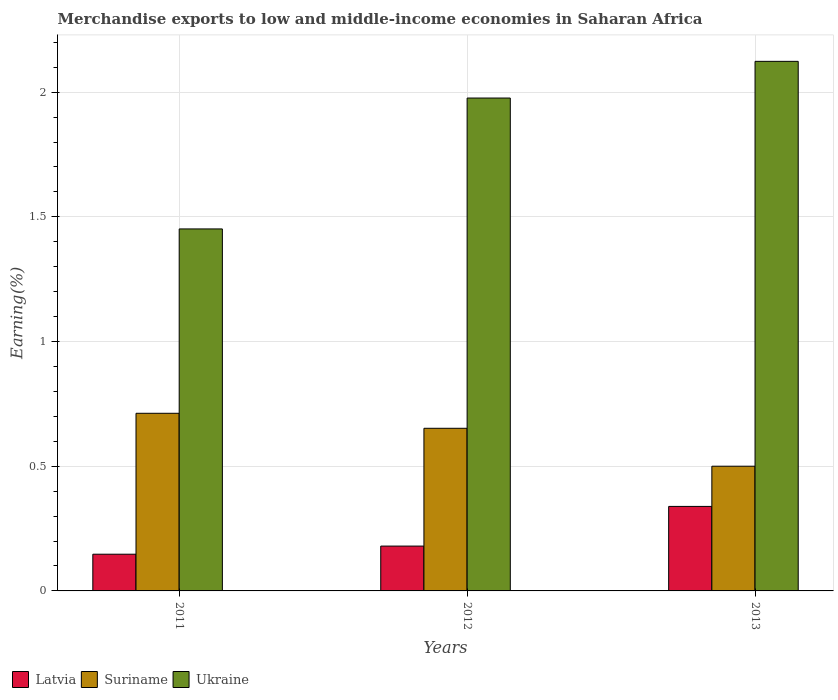What is the percentage of amount earned from merchandise exports in Suriname in 2013?
Give a very brief answer. 0.5. Across all years, what is the maximum percentage of amount earned from merchandise exports in Latvia?
Provide a succinct answer. 0.34. Across all years, what is the minimum percentage of amount earned from merchandise exports in Ukraine?
Give a very brief answer. 1.45. In which year was the percentage of amount earned from merchandise exports in Ukraine maximum?
Provide a succinct answer. 2013. In which year was the percentage of amount earned from merchandise exports in Latvia minimum?
Give a very brief answer. 2011. What is the total percentage of amount earned from merchandise exports in Suriname in the graph?
Keep it short and to the point. 1.86. What is the difference between the percentage of amount earned from merchandise exports in Latvia in 2011 and that in 2012?
Give a very brief answer. -0.03. What is the difference between the percentage of amount earned from merchandise exports in Suriname in 2011 and the percentage of amount earned from merchandise exports in Ukraine in 2012?
Your answer should be compact. -1.26. What is the average percentage of amount earned from merchandise exports in Suriname per year?
Offer a terse response. 0.62. In the year 2013, what is the difference between the percentage of amount earned from merchandise exports in Ukraine and percentage of amount earned from merchandise exports in Suriname?
Your answer should be very brief. 1.62. In how many years, is the percentage of amount earned from merchandise exports in Latvia greater than 2 %?
Give a very brief answer. 0. What is the ratio of the percentage of amount earned from merchandise exports in Ukraine in 2011 to that in 2012?
Give a very brief answer. 0.73. Is the difference between the percentage of amount earned from merchandise exports in Ukraine in 2011 and 2013 greater than the difference between the percentage of amount earned from merchandise exports in Suriname in 2011 and 2013?
Provide a succinct answer. No. What is the difference between the highest and the second highest percentage of amount earned from merchandise exports in Ukraine?
Make the answer very short. 0.15. What is the difference between the highest and the lowest percentage of amount earned from merchandise exports in Suriname?
Give a very brief answer. 0.21. What does the 1st bar from the left in 2013 represents?
Provide a short and direct response. Latvia. What does the 1st bar from the right in 2012 represents?
Keep it short and to the point. Ukraine. Are all the bars in the graph horizontal?
Ensure brevity in your answer.  No. Does the graph contain any zero values?
Your response must be concise. No. Where does the legend appear in the graph?
Ensure brevity in your answer.  Bottom left. How many legend labels are there?
Keep it short and to the point. 3. What is the title of the graph?
Keep it short and to the point. Merchandise exports to low and middle-income economies in Saharan Africa. What is the label or title of the Y-axis?
Provide a short and direct response. Earning(%). What is the Earning(%) in Latvia in 2011?
Ensure brevity in your answer.  0.15. What is the Earning(%) of Suriname in 2011?
Your answer should be compact. 0.71. What is the Earning(%) of Ukraine in 2011?
Ensure brevity in your answer.  1.45. What is the Earning(%) in Latvia in 2012?
Ensure brevity in your answer.  0.18. What is the Earning(%) of Suriname in 2012?
Ensure brevity in your answer.  0.65. What is the Earning(%) in Ukraine in 2012?
Your answer should be compact. 1.98. What is the Earning(%) in Latvia in 2013?
Your response must be concise. 0.34. What is the Earning(%) of Suriname in 2013?
Make the answer very short. 0.5. What is the Earning(%) in Ukraine in 2013?
Your response must be concise. 2.12. Across all years, what is the maximum Earning(%) of Latvia?
Your answer should be compact. 0.34. Across all years, what is the maximum Earning(%) in Suriname?
Offer a very short reply. 0.71. Across all years, what is the maximum Earning(%) of Ukraine?
Keep it short and to the point. 2.12. Across all years, what is the minimum Earning(%) in Latvia?
Offer a terse response. 0.15. Across all years, what is the minimum Earning(%) of Suriname?
Ensure brevity in your answer.  0.5. Across all years, what is the minimum Earning(%) in Ukraine?
Make the answer very short. 1.45. What is the total Earning(%) in Latvia in the graph?
Provide a succinct answer. 0.67. What is the total Earning(%) of Suriname in the graph?
Offer a terse response. 1.86. What is the total Earning(%) of Ukraine in the graph?
Offer a terse response. 5.55. What is the difference between the Earning(%) of Latvia in 2011 and that in 2012?
Ensure brevity in your answer.  -0.03. What is the difference between the Earning(%) of Suriname in 2011 and that in 2012?
Make the answer very short. 0.06. What is the difference between the Earning(%) of Ukraine in 2011 and that in 2012?
Your response must be concise. -0.52. What is the difference between the Earning(%) in Latvia in 2011 and that in 2013?
Your answer should be very brief. -0.19. What is the difference between the Earning(%) in Suriname in 2011 and that in 2013?
Make the answer very short. 0.21. What is the difference between the Earning(%) in Ukraine in 2011 and that in 2013?
Ensure brevity in your answer.  -0.67. What is the difference between the Earning(%) of Latvia in 2012 and that in 2013?
Provide a succinct answer. -0.16. What is the difference between the Earning(%) of Suriname in 2012 and that in 2013?
Your answer should be very brief. 0.15. What is the difference between the Earning(%) of Ukraine in 2012 and that in 2013?
Make the answer very short. -0.15. What is the difference between the Earning(%) of Latvia in 2011 and the Earning(%) of Suriname in 2012?
Your answer should be very brief. -0.5. What is the difference between the Earning(%) in Latvia in 2011 and the Earning(%) in Ukraine in 2012?
Your answer should be compact. -1.83. What is the difference between the Earning(%) of Suriname in 2011 and the Earning(%) of Ukraine in 2012?
Your response must be concise. -1.26. What is the difference between the Earning(%) of Latvia in 2011 and the Earning(%) of Suriname in 2013?
Make the answer very short. -0.35. What is the difference between the Earning(%) in Latvia in 2011 and the Earning(%) in Ukraine in 2013?
Give a very brief answer. -1.98. What is the difference between the Earning(%) in Suriname in 2011 and the Earning(%) in Ukraine in 2013?
Provide a succinct answer. -1.41. What is the difference between the Earning(%) of Latvia in 2012 and the Earning(%) of Suriname in 2013?
Provide a short and direct response. -0.32. What is the difference between the Earning(%) in Latvia in 2012 and the Earning(%) in Ukraine in 2013?
Make the answer very short. -1.94. What is the difference between the Earning(%) of Suriname in 2012 and the Earning(%) of Ukraine in 2013?
Your answer should be very brief. -1.47. What is the average Earning(%) in Latvia per year?
Your answer should be very brief. 0.22. What is the average Earning(%) in Suriname per year?
Your response must be concise. 0.62. What is the average Earning(%) of Ukraine per year?
Your answer should be very brief. 1.85. In the year 2011, what is the difference between the Earning(%) in Latvia and Earning(%) in Suriname?
Provide a succinct answer. -0.57. In the year 2011, what is the difference between the Earning(%) of Latvia and Earning(%) of Ukraine?
Your answer should be compact. -1.3. In the year 2011, what is the difference between the Earning(%) in Suriname and Earning(%) in Ukraine?
Your answer should be compact. -0.74. In the year 2012, what is the difference between the Earning(%) in Latvia and Earning(%) in Suriname?
Give a very brief answer. -0.47. In the year 2012, what is the difference between the Earning(%) in Latvia and Earning(%) in Ukraine?
Provide a short and direct response. -1.8. In the year 2012, what is the difference between the Earning(%) of Suriname and Earning(%) of Ukraine?
Your response must be concise. -1.32. In the year 2013, what is the difference between the Earning(%) in Latvia and Earning(%) in Suriname?
Offer a very short reply. -0.16. In the year 2013, what is the difference between the Earning(%) of Latvia and Earning(%) of Ukraine?
Give a very brief answer. -1.78. In the year 2013, what is the difference between the Earning(%) in Suriname and Earning(%) in Ukraine?
Give a very brief answer. -1.62. What is the ratio of the Earning(%) of Latvia in 2011 to that in 2012?
Make the answer very short. 0.82. What is the ratio of the Earning(%) in Suriname in 2011 to that in 2012?
Keep it short and to the point. 1.09. What is the ratio of the Earning(%) of Ukraine in 2011 to that in 2012?
Offer a terse response. 0.73. What is the ratio of the Earning(%) of Latvia in 2011 to that in 2013?
Offer a terse response. 0.43. What is the ratio of the Earning(%) in Suriname in 2011 to that in 2013?
Offer a very short reply. 1.42. What is the ratio of the Earning(%) in Ukraine in 2011 to that in 2013?
Your answer should be compact. 0.68. What is the ratio of the Earning(%) of Latvia in 2012 to that in 2013?
Give a very brief answer. 0.53. What is the ratio of the Earning(%) in Suriname in 2012 to that in 2013?
Your answer should be compact. 1.3. What is the ratio of the Earning(%) of Ukraine in 2012 to that in 2013?
Your answer should be compact. 0.93. What is the difference between the highest and the second highest Earning(%) in Latvia?
Make the answer very short. 0.16. What is the difference between the highest and the second highest Earning(%) in Suriname?
Your response must be concise. 0.06. What is the difference between the highest and the second highest Earning(%) of Ukraine?
Make the answer very short. 0.15. What is the difference between the highest and the lowest Earning(%) of Latvia?
Keep it short and to the point. 0.19. What is the difference between the highest and the lowest Earning(%) in Suriname?
Provide a succinct answer. 0.21. What is the difference between the highest and the lowest Earning(%) in Ukraine?
Your answer should be very brief. 0.67. 